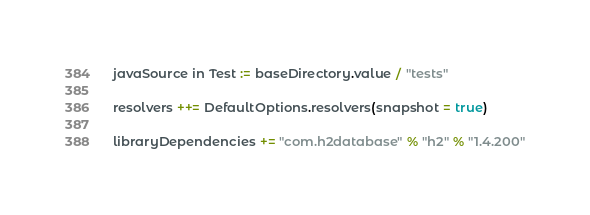<code> <loc_0><loc_0><loc_500><loc_500><_Scala_>
javaSource in Test := baseDirectory.value / "tests"

resolvers ++= DefaultOptions.resolvers(snapshot = true)

libraryDependencies += "com.h2database" % "h2" % "1.4.200"
</code> 